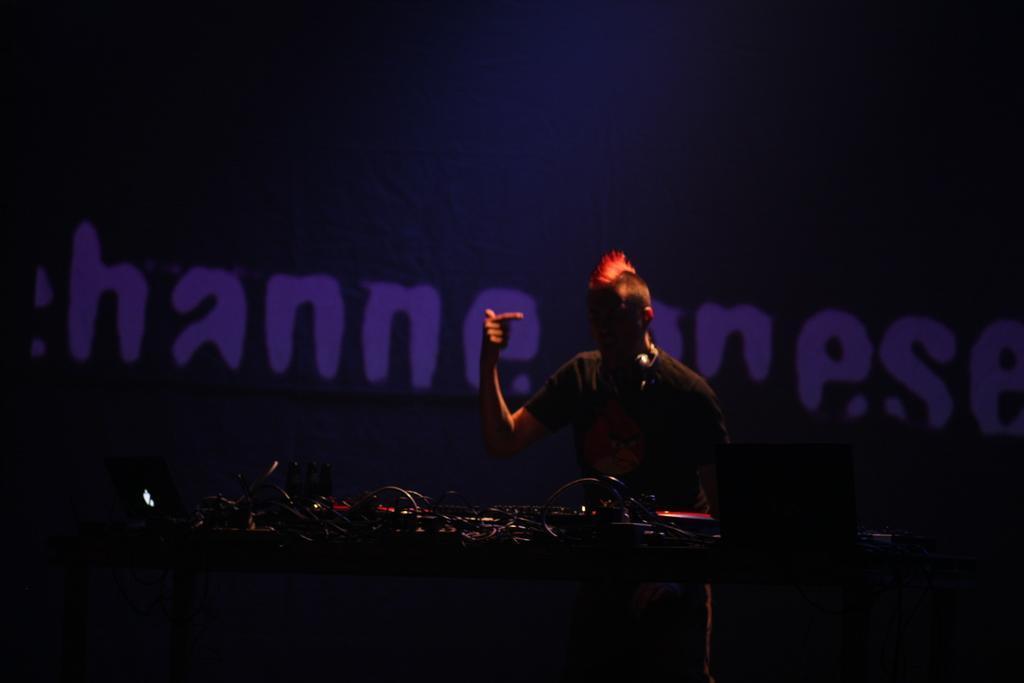Describe this image in one or two sentences. In the foreground of the picture there is a music control system, cables. In the center of the picture there is a person standing. In the background there is text. The background is dark. 